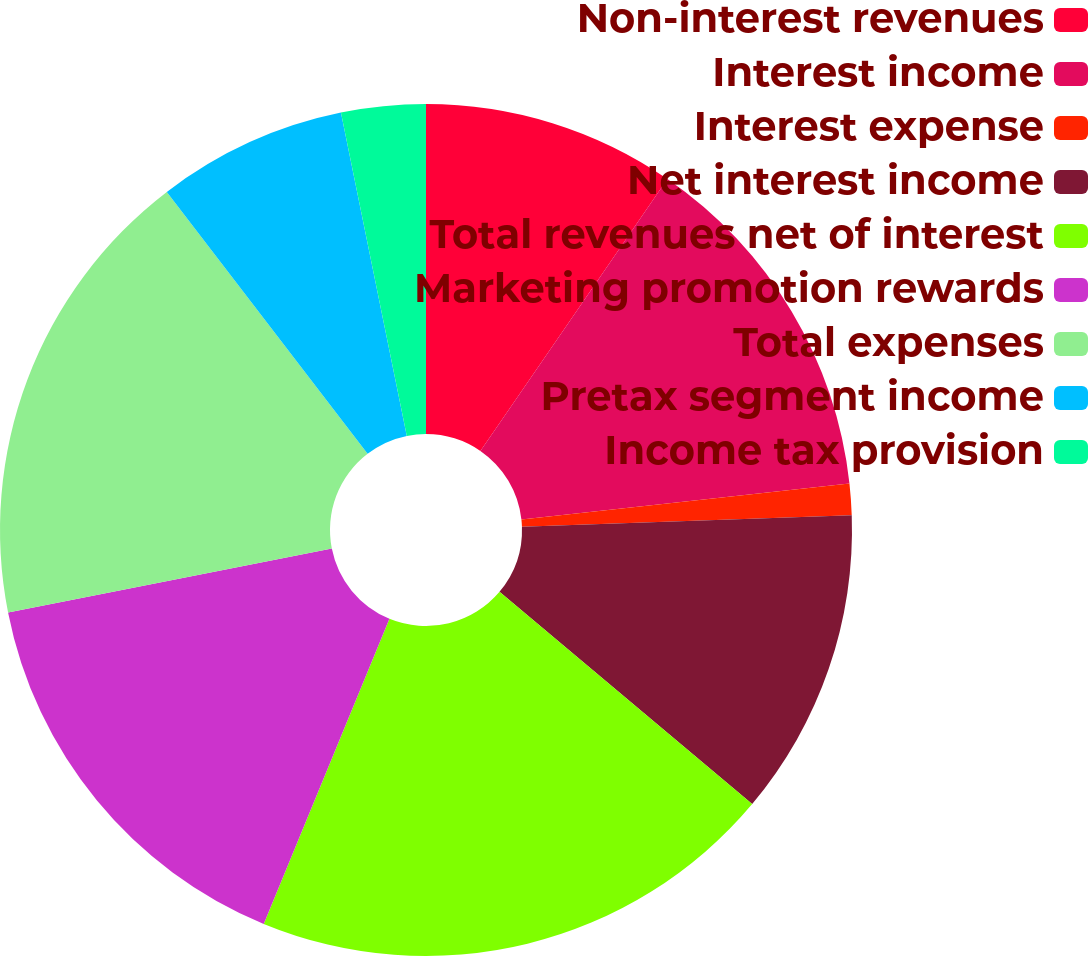Convert chart. <chart><loc_0><loc_0><loc_500><loc_500><pie_chart><fcel>Non-interest revenues<fcel>Interest income<fcel>Interest expense<fcel>Net interest income<fcel>Total revenues net of interest<fcel>Marketing promotion rewards<fcel>Total expenses<fcel>Pretax segment income<fcel>Income tax provision<nl><fcel>9.59%<fcel>13.67%<fcel>1.19%<fcel>11.67%<fcel>20.1%<fcel>15.68%<fcel>17.69%<fcel>7.21%<fcel>3.2%<nl></chart> 